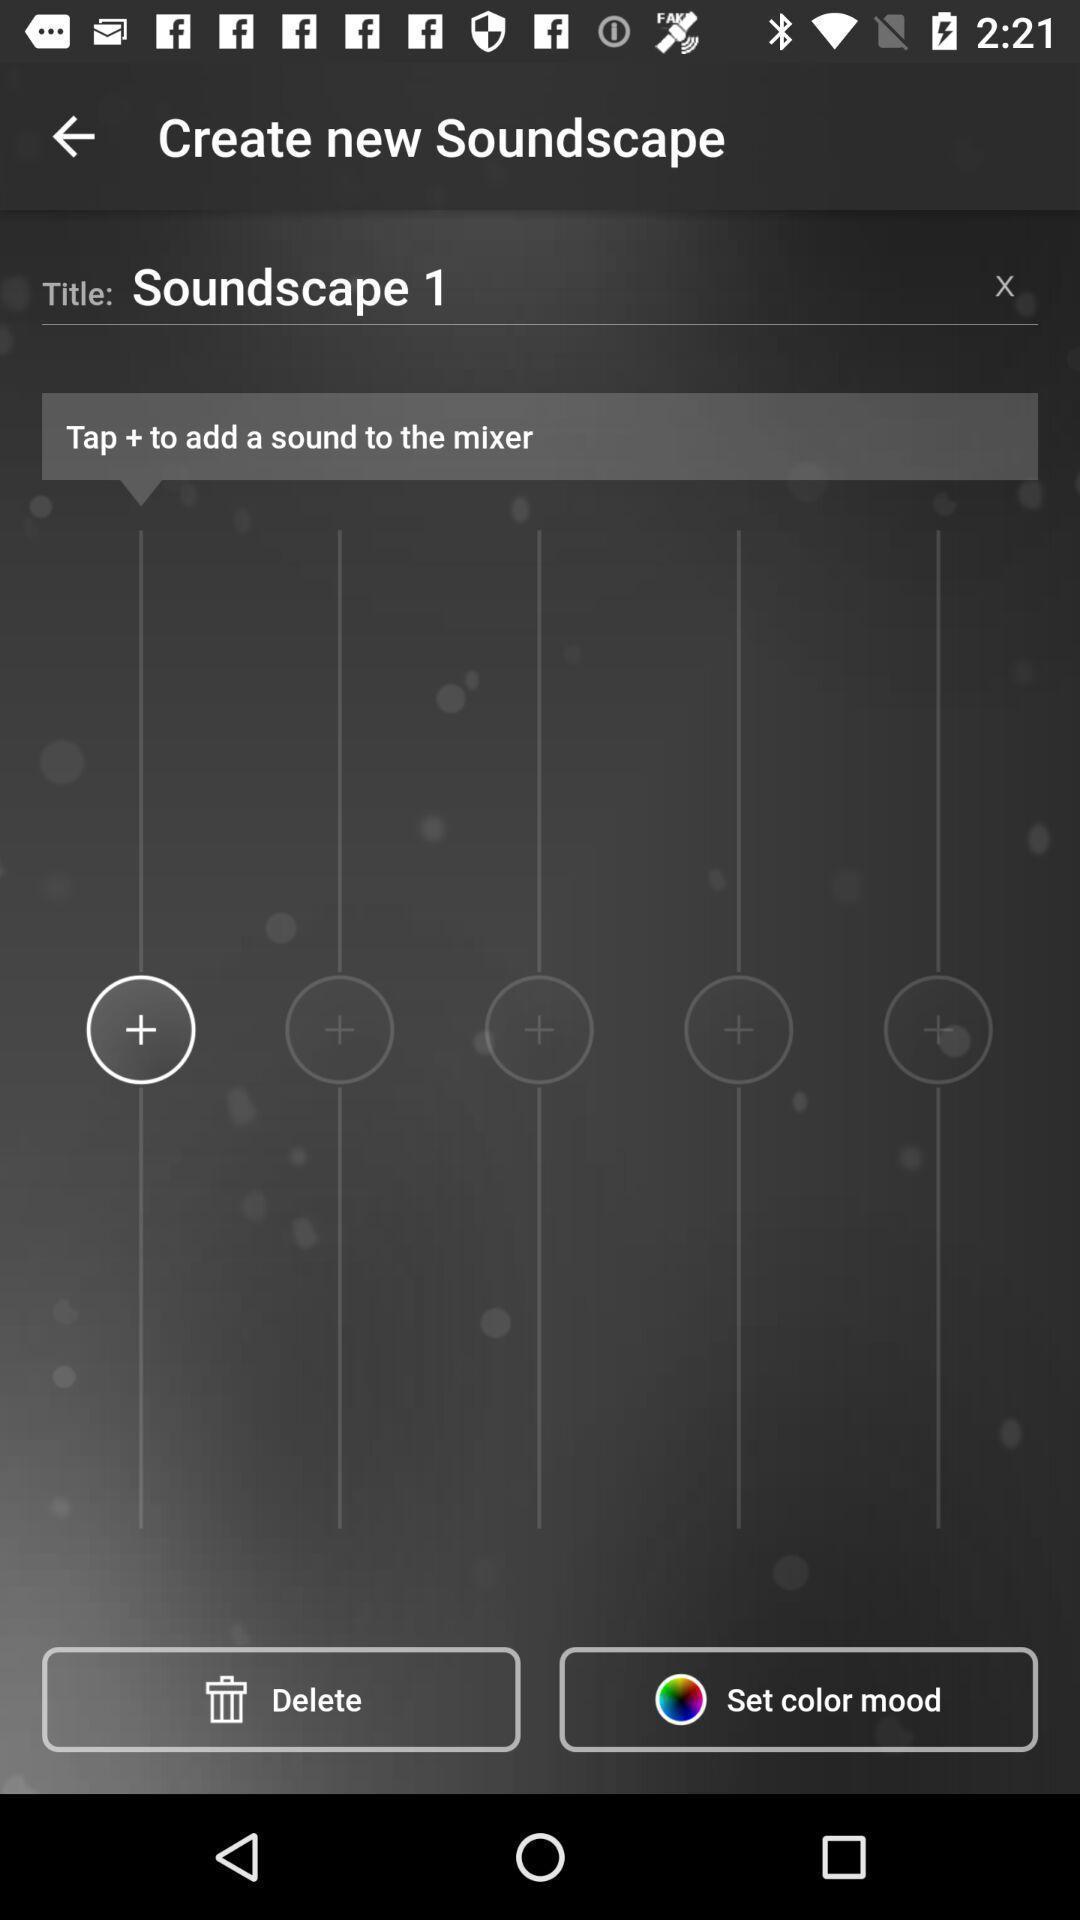Tell me what you see in this picture. Page showing information of audio. 